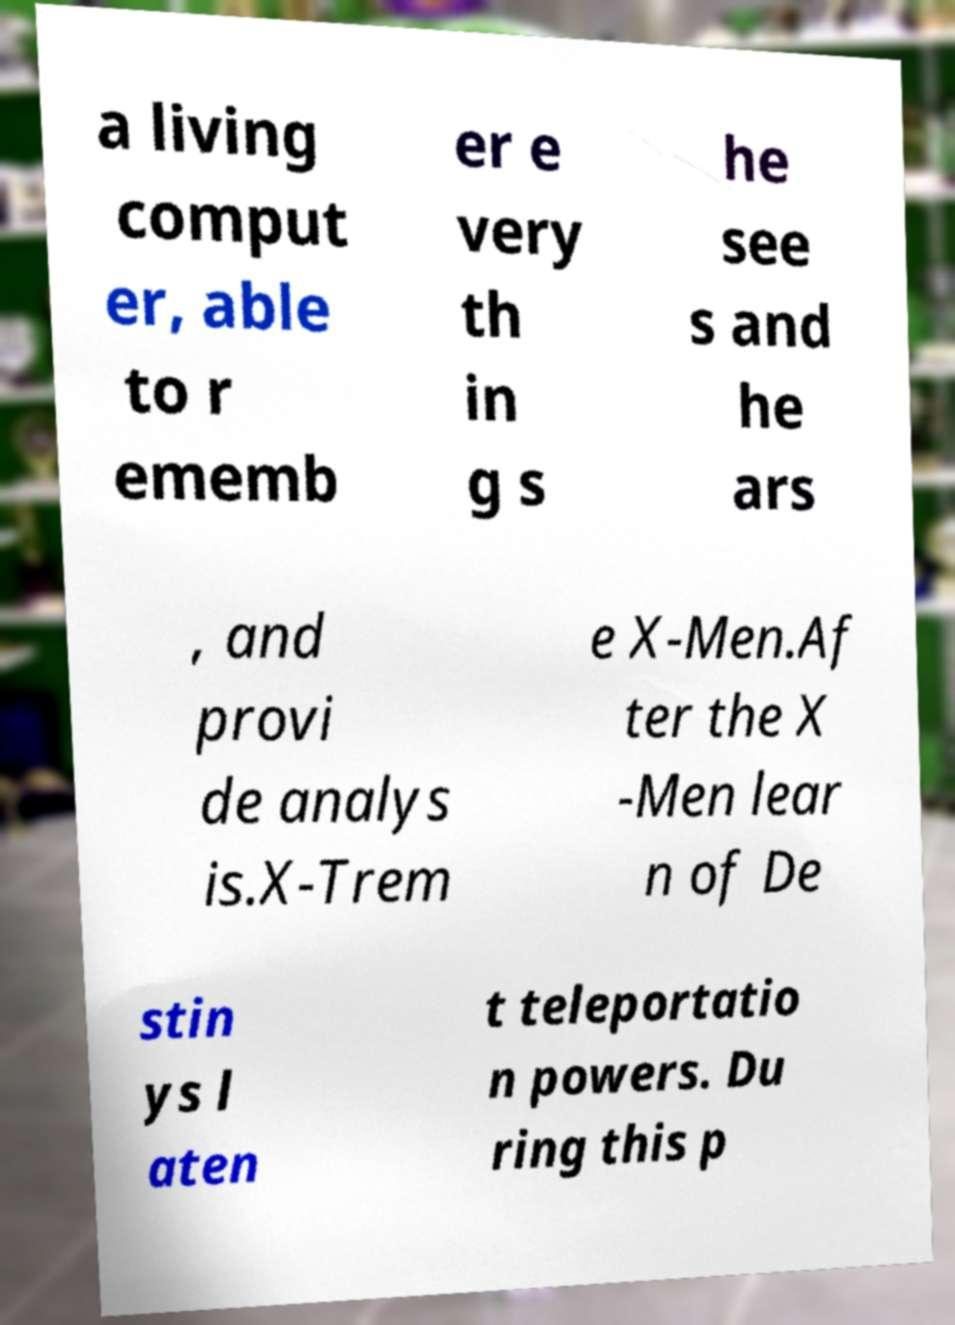I need the written content from this picture converted into text. Can you do that? a living comput er, able to r ememb er e very th in g s he see s and he ars , and provi de analys is.X-Trem e X-Men.Af ter the X -Men lear n of De stin ys l aten t teleportatio n powers. Du ring this p 